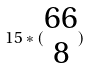<formula> <loc_0><loc_0><loc_500><loc_500>1 5 * ( \begin{matrix} 6 6 \\ 8 \end{matrix} )</formula> 